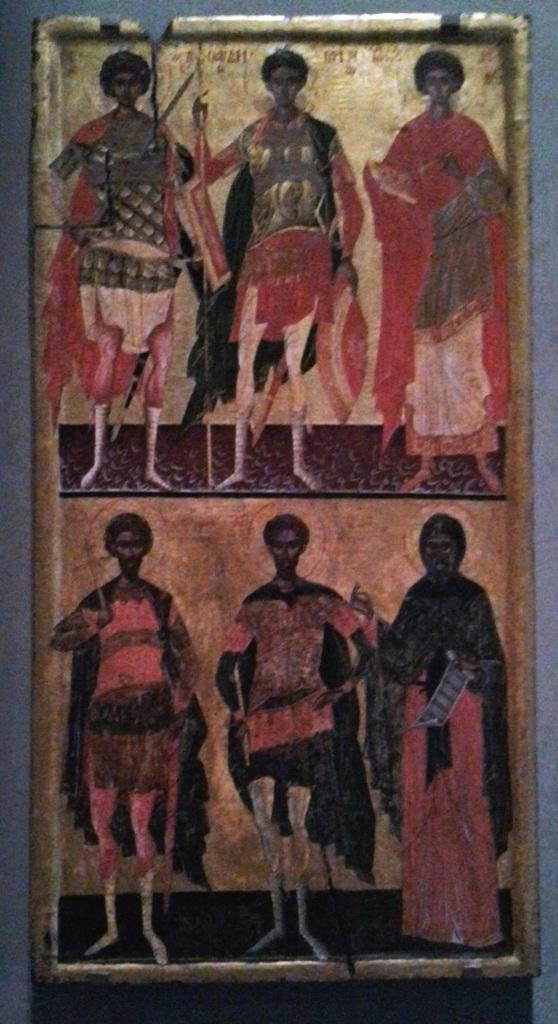Can you describe this image briefly? In the foreground of this image, there is a frame. 